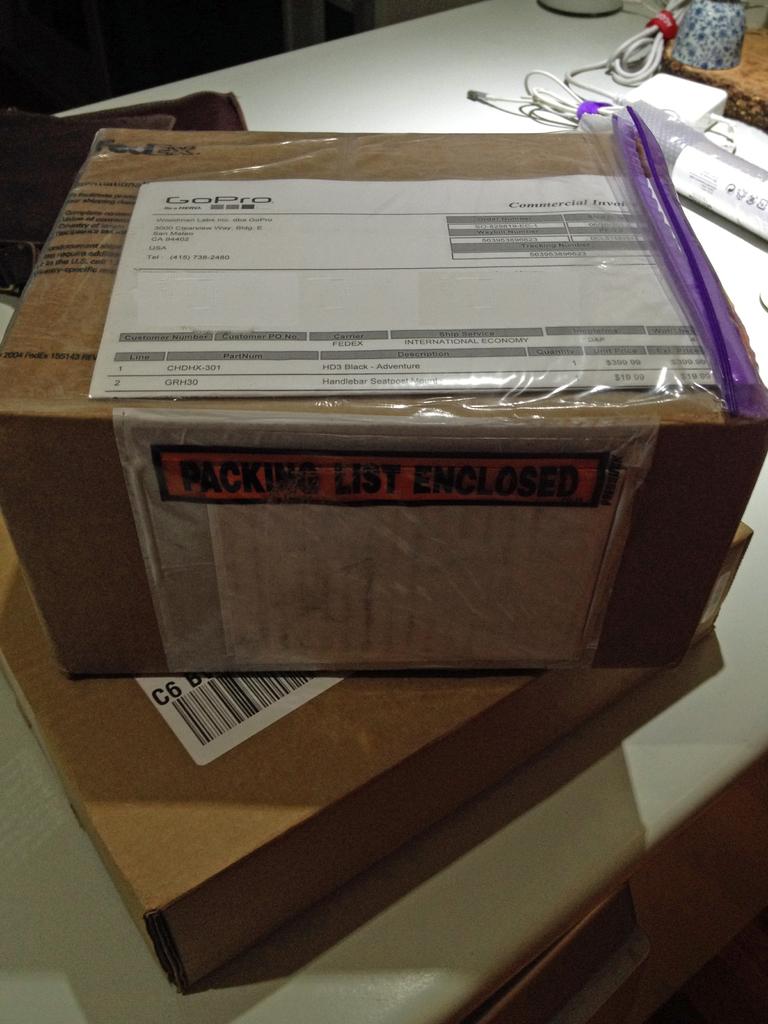What does the yellow label say?
Provide a short and direct response. Packing list enclosed. What is enclosed?
Your response must be concise. Packing list. 